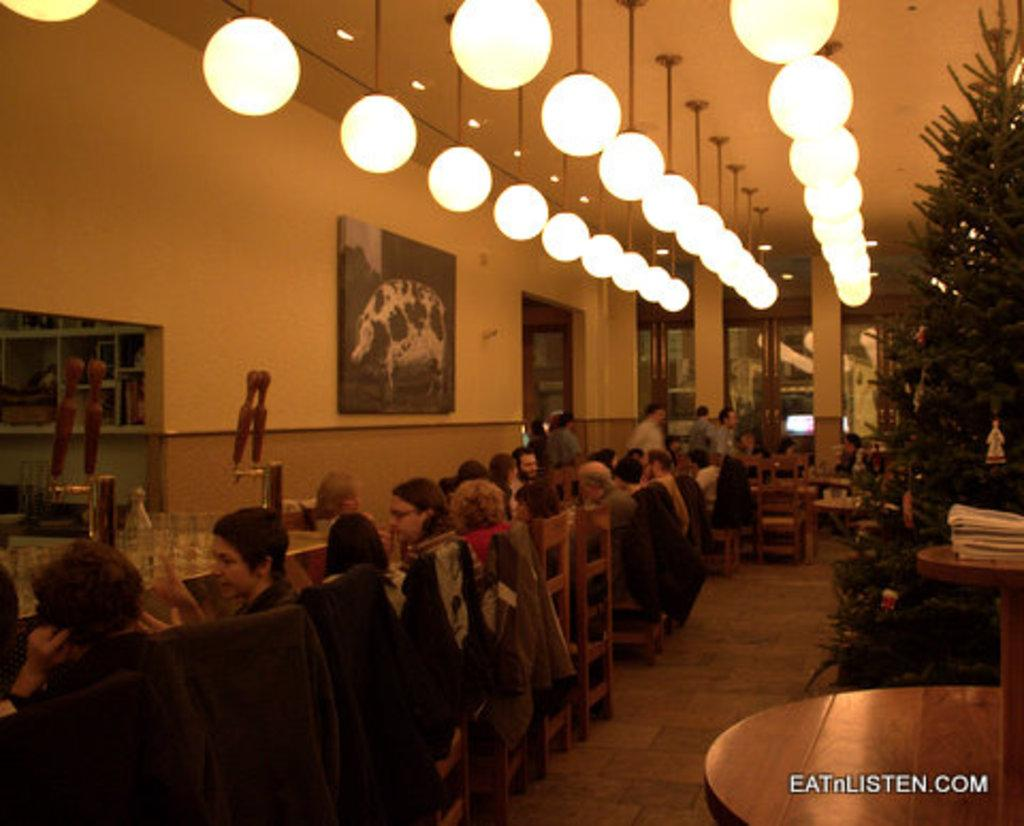What is the primary activity of the people in the image? The people in the image are sitting on chairs. How many tables are visible in the image? There are multiple tables in the image. What type of lighting is present in the image? There are lights hanging from the ceiling in the image. What type of can does the farmer use to collect milk from the flock in the image? There is no farmer, can, or flock present in the image. 